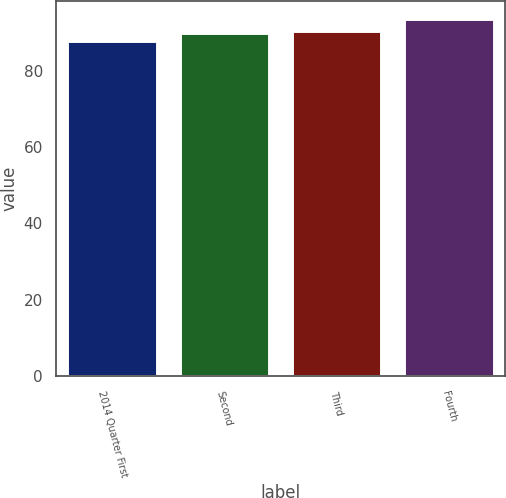Convert chart to OTSL. <chart><loc_0><loc_0><loc_500><loc_500><bar_chart><fcel>2014 Quarter First<fcel>Second<fcel>Third<fcel>Fourth<nl><fcel>87.8<fcel>89.85<fcel>90.41<fcel>93.45<nl></chart> 